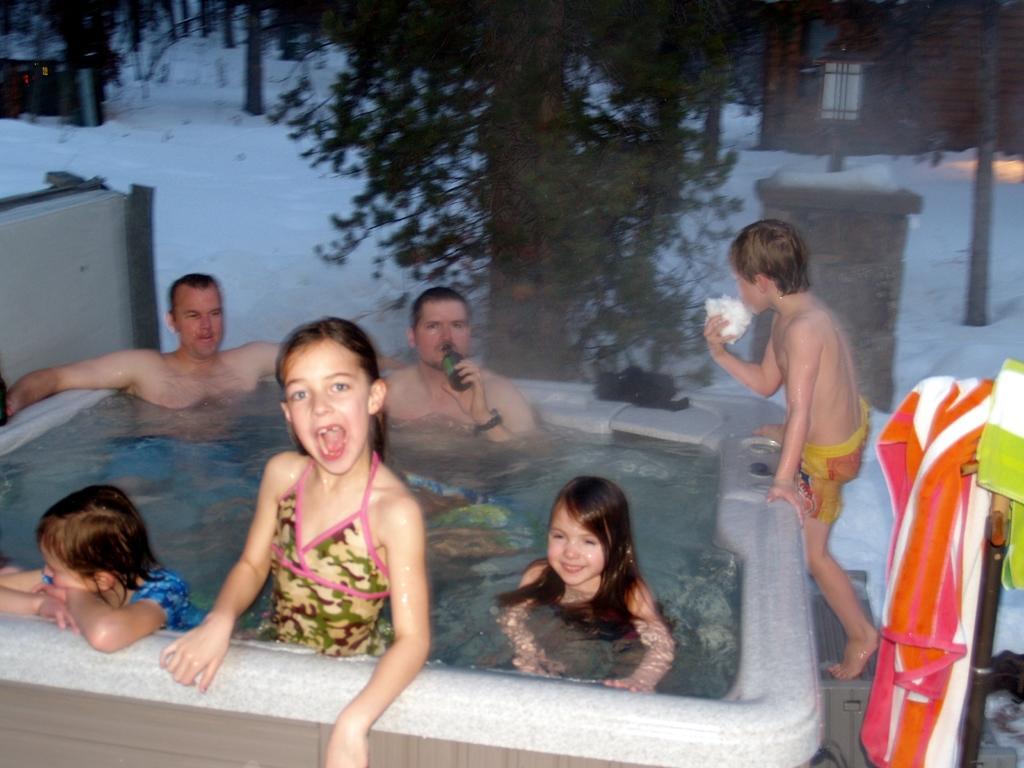How would you summarize this image in a sentence or two? In this picture we can see a few kids and two men in the tub. We can see the water in the tub. There is a person holding a bottle and a black object is visible on the tub. We can see a boy holding an object in his hand. There is a lantern visible on the pole. We can see the snow. There are a few towels and other objects on the right side. We can see a few trees, tree trunks and houses in the background. 